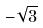<formula> <loc_0><loc_0><loc_500><loc_500>- \sqrt { 3 }</formula> 